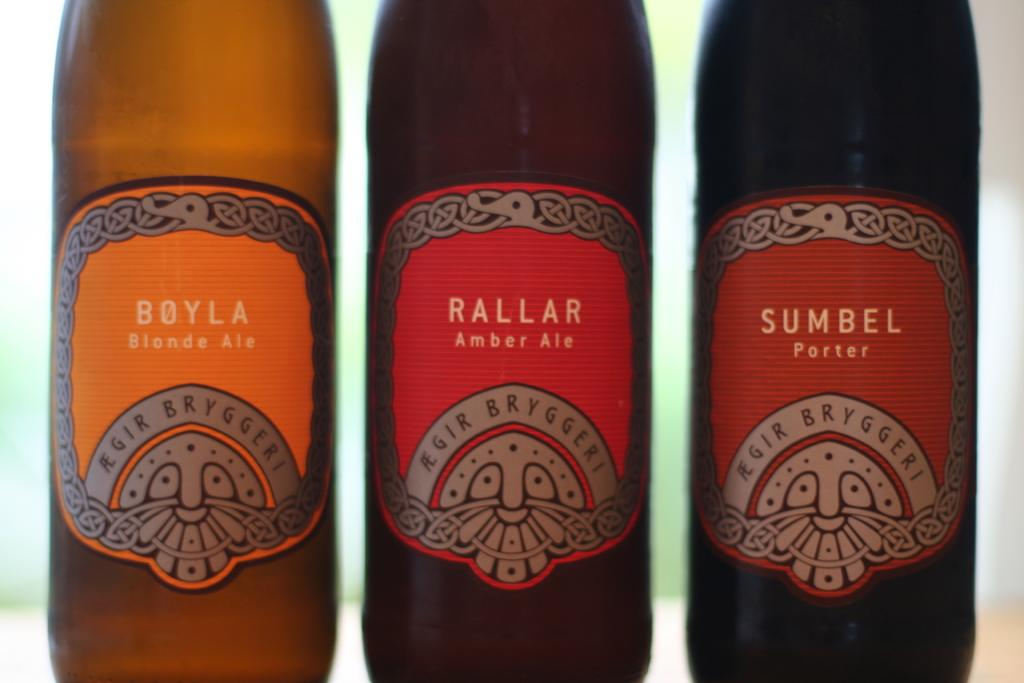Provide a one-sentence caption for the provided image. Three bottles of different types of beer are shown, one of which is a Porter. 